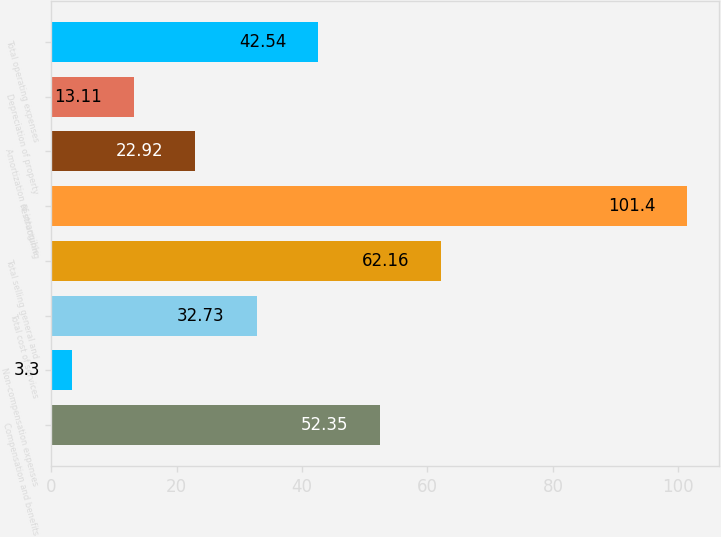Convert chart to OTSL. <chart><loc_0><loc_0><loc_500><loc_500><bar_chart><fcel>Compensation and benefits<fcel>Non-compensation expenses<fcel>Total cost of services<fcel>Total selling general and<fcel>Restructuring<fcel>Amortization of intangible<fcel>Depreciation of property<fcel>Total operating expenses<nl><fcel>52.35<fcel>3.3<fcel>32.73<fcel>62.16<fcel>101.4<fcel>22.92<fcel>13.11<fcel>42.54<nl></chart> 